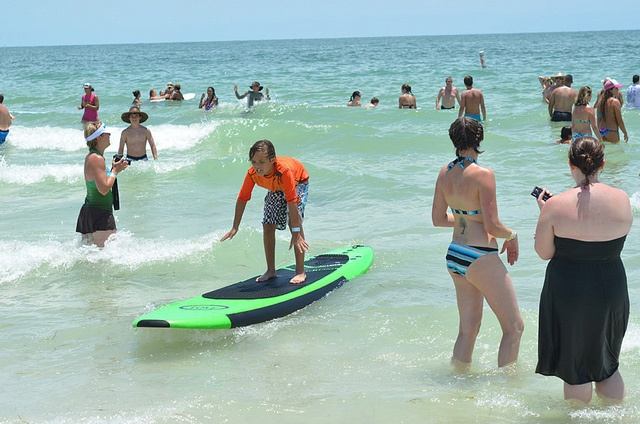Describe the objects in this image and their specific colors. I can see people in lightblue, black, darkgray, and gray tones, people in lightblue, gray, and black tones, surfboard in lightblue, lightgreen, blue, and darkblue tones, people in lightblue, gray, and darkgray tones, and people in lightblue, gray, maroon, and black tones in this image. 